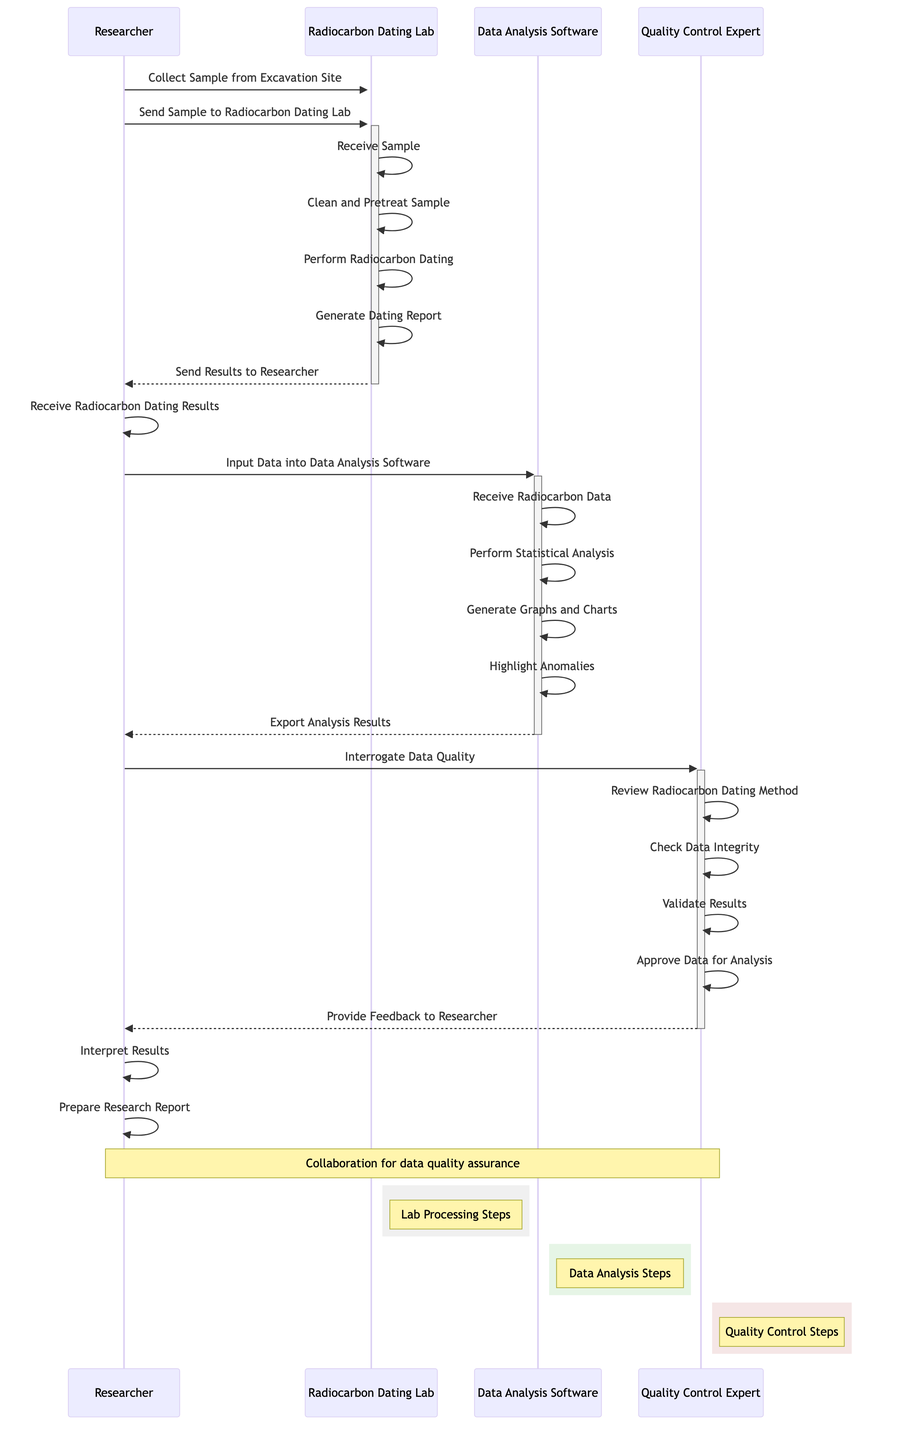What is the first action performed by the researcher? The first action listed under the Researcher's entity is "Collect Sample from Excavation Site." This is the initial step taken before sending the sample to the lab.
Answer: Collect Sample from Excavation Site How many actions are performed by the Radiocarbon Dating Lab? By counting the actions listed under the Radiocarbon Dating Lab entity, there are five actions: Receive Sample, Clean and Pretreat Sample, Perform Radiocarbon Dating, Generate Dating Report, and Send Results to Researcher.
Answer: 5 Who sends the results to the researcher? The arrow indicating the flow shows that the Radiocarbon Dating Lab sends the results to the Researcher after generating the dating report.
Answer: Radiocarbon Dating Lab What step follows the inputting of data into the Data Analysis Software? After the Researcher inputs data into the Data Analysis Software, the next step is for the software to receive the Radiocarbon data. This follows directly in the sequence.
Answer: Receive Radiocarbon Data How many entities are involved in this sequence diagram? The diagram contains four entities: Researcher, Radiocarbon Dating Lab, Data Analysis Software, and Quality Control Expert. Counting these listed entities gives the total.
Answer: 4 What is the last action taken before preparing the research report? Before preparing the research report, the Researcher interprets the results, which is the action immediately preceding the final step of preparation.
Answer: Interpret Results Which entity performs statistical analysis? The Data Analysis Software is responsible for performing statistical analysis, as indicated in the flow of actions associated with that entity.
Answer: Data Analysis Software What does the Quality Control Expert provide to the Researcher? The Quality Control Expert provides feedback to the Researcher after validating results and approving data, which is the last action related to the Quality Control Expert in the sequence.
Answer: Provide Feedback to Researcher 